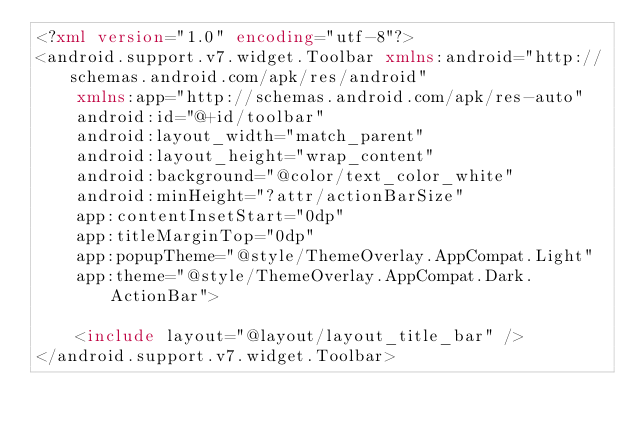Convert code to text. <code><loc_0><loc_0><loc_500><loc_500><_XML_><?xml version="1.0" encoding="utf-8"?>
<android.support.v7.widget.Toolbar xmlns:android="http://schemas.android.com/apk/res/android"
    xmlns:app="http://schemas.android.com/apk/res-auto"
    android:id="@+id/toolbar"
    android:layout_width="match_parent"
    android:layout_height="wrap_content"
    android:background="@color/text_color_white"
    android:minHeight="?attr/actionBarSize"
    app:contentInsetStart="0dp"
    app:titleMarginTop="0dp"
    app:popupTheme="@style/ThemeOverlay.AppCompat.Light"
    app:theme="@style/ThemeOverlay.AppCompat.Dark.ActionBar">

    <include layout="@layout/layout_title_bar" />
</android.support.v7.widget.Toolbar>
</code> 